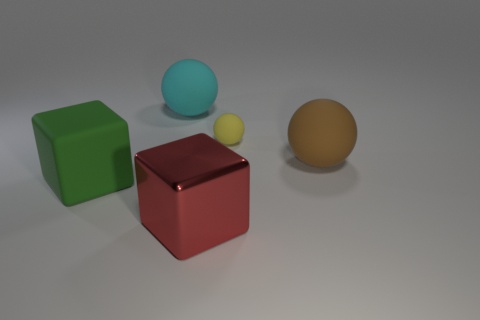Add 2 big brown rubber things. How many objects exist? 7 Subtract all balls. How many objects are left? 2 Subtract 0 yellow blocks. How many objects are left? 5 Subtract all gray metal balls. Subtract all large red cubes. How many objects are left? 4 Add 4 yellow matte spheres. How many yellow matte spheres are left? 5 Add 4 small gray blocks. How many small gray blocks exist? 4 